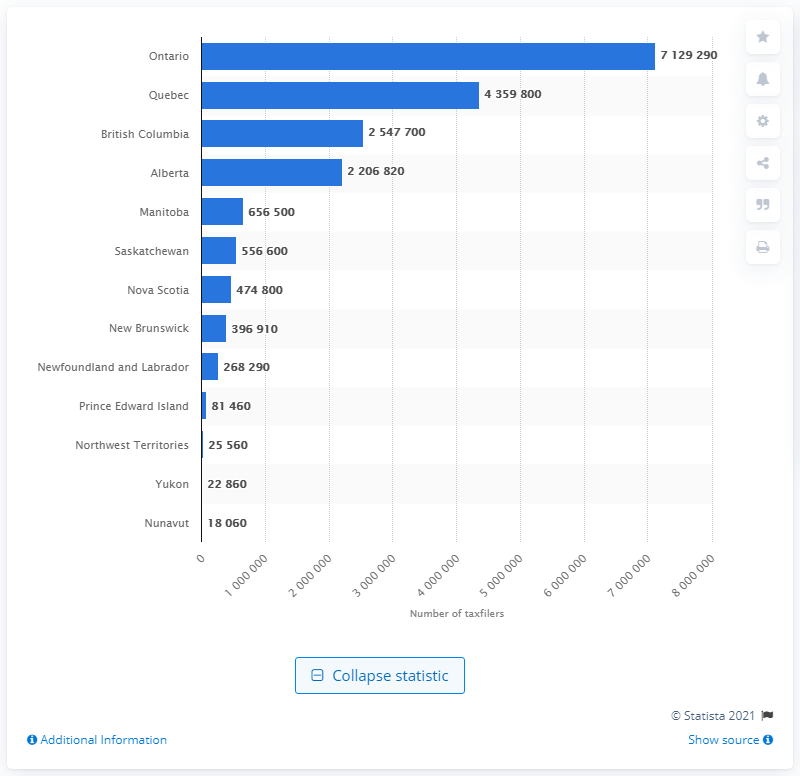Outline some significant characteristics in this image. In 2018, there were 7,129,290 wage, salary, and commission workers employed in the province of Ontario. 